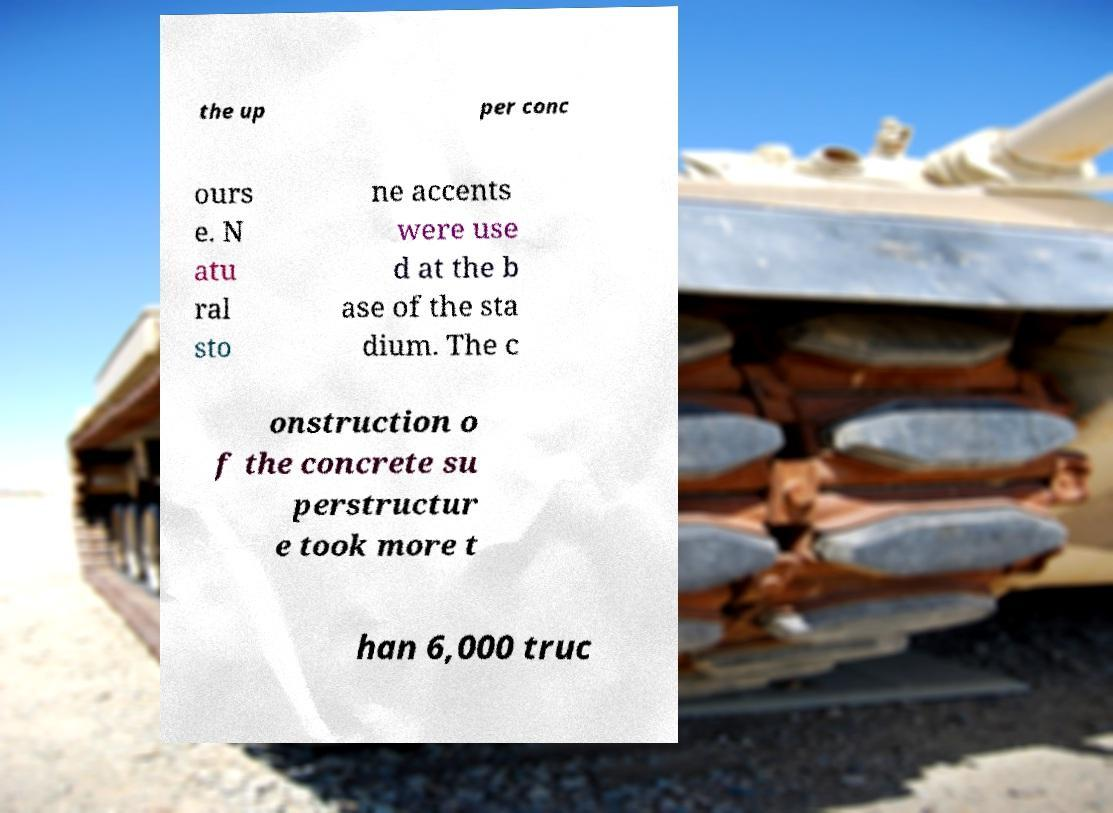Could you assist in decoding the text presented in this image and type it out clearly? the up per conc ours e. N atu ral sto ne accents were use d at the b ase of the sta dium. The c onstruction o f the concrete su perstructur e took more t han 6,000 truc 